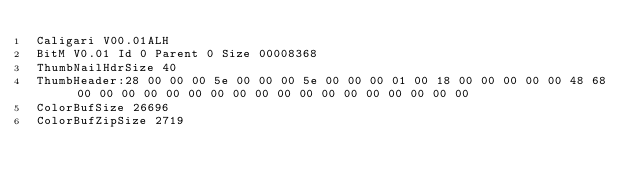<code> <loc_0><loc_0><loc_500><loc_500><_COBOL_>Caligari V00.01ALH             
BitM V0.01 Id 0 Parent 0 Size 00008368
ThumbNailHdrSize 40
ThumbHeader:28 00 00 00 5e 00 00 00 5e 00 00 00 01 00 18 00 00 00 00 00 48 68 00 00 00 00 00 00 00 00 00 00 00 00 00 00 00 00 00 00 
ColorBufSize 26696
ColorBufZipSize 2719</code> 